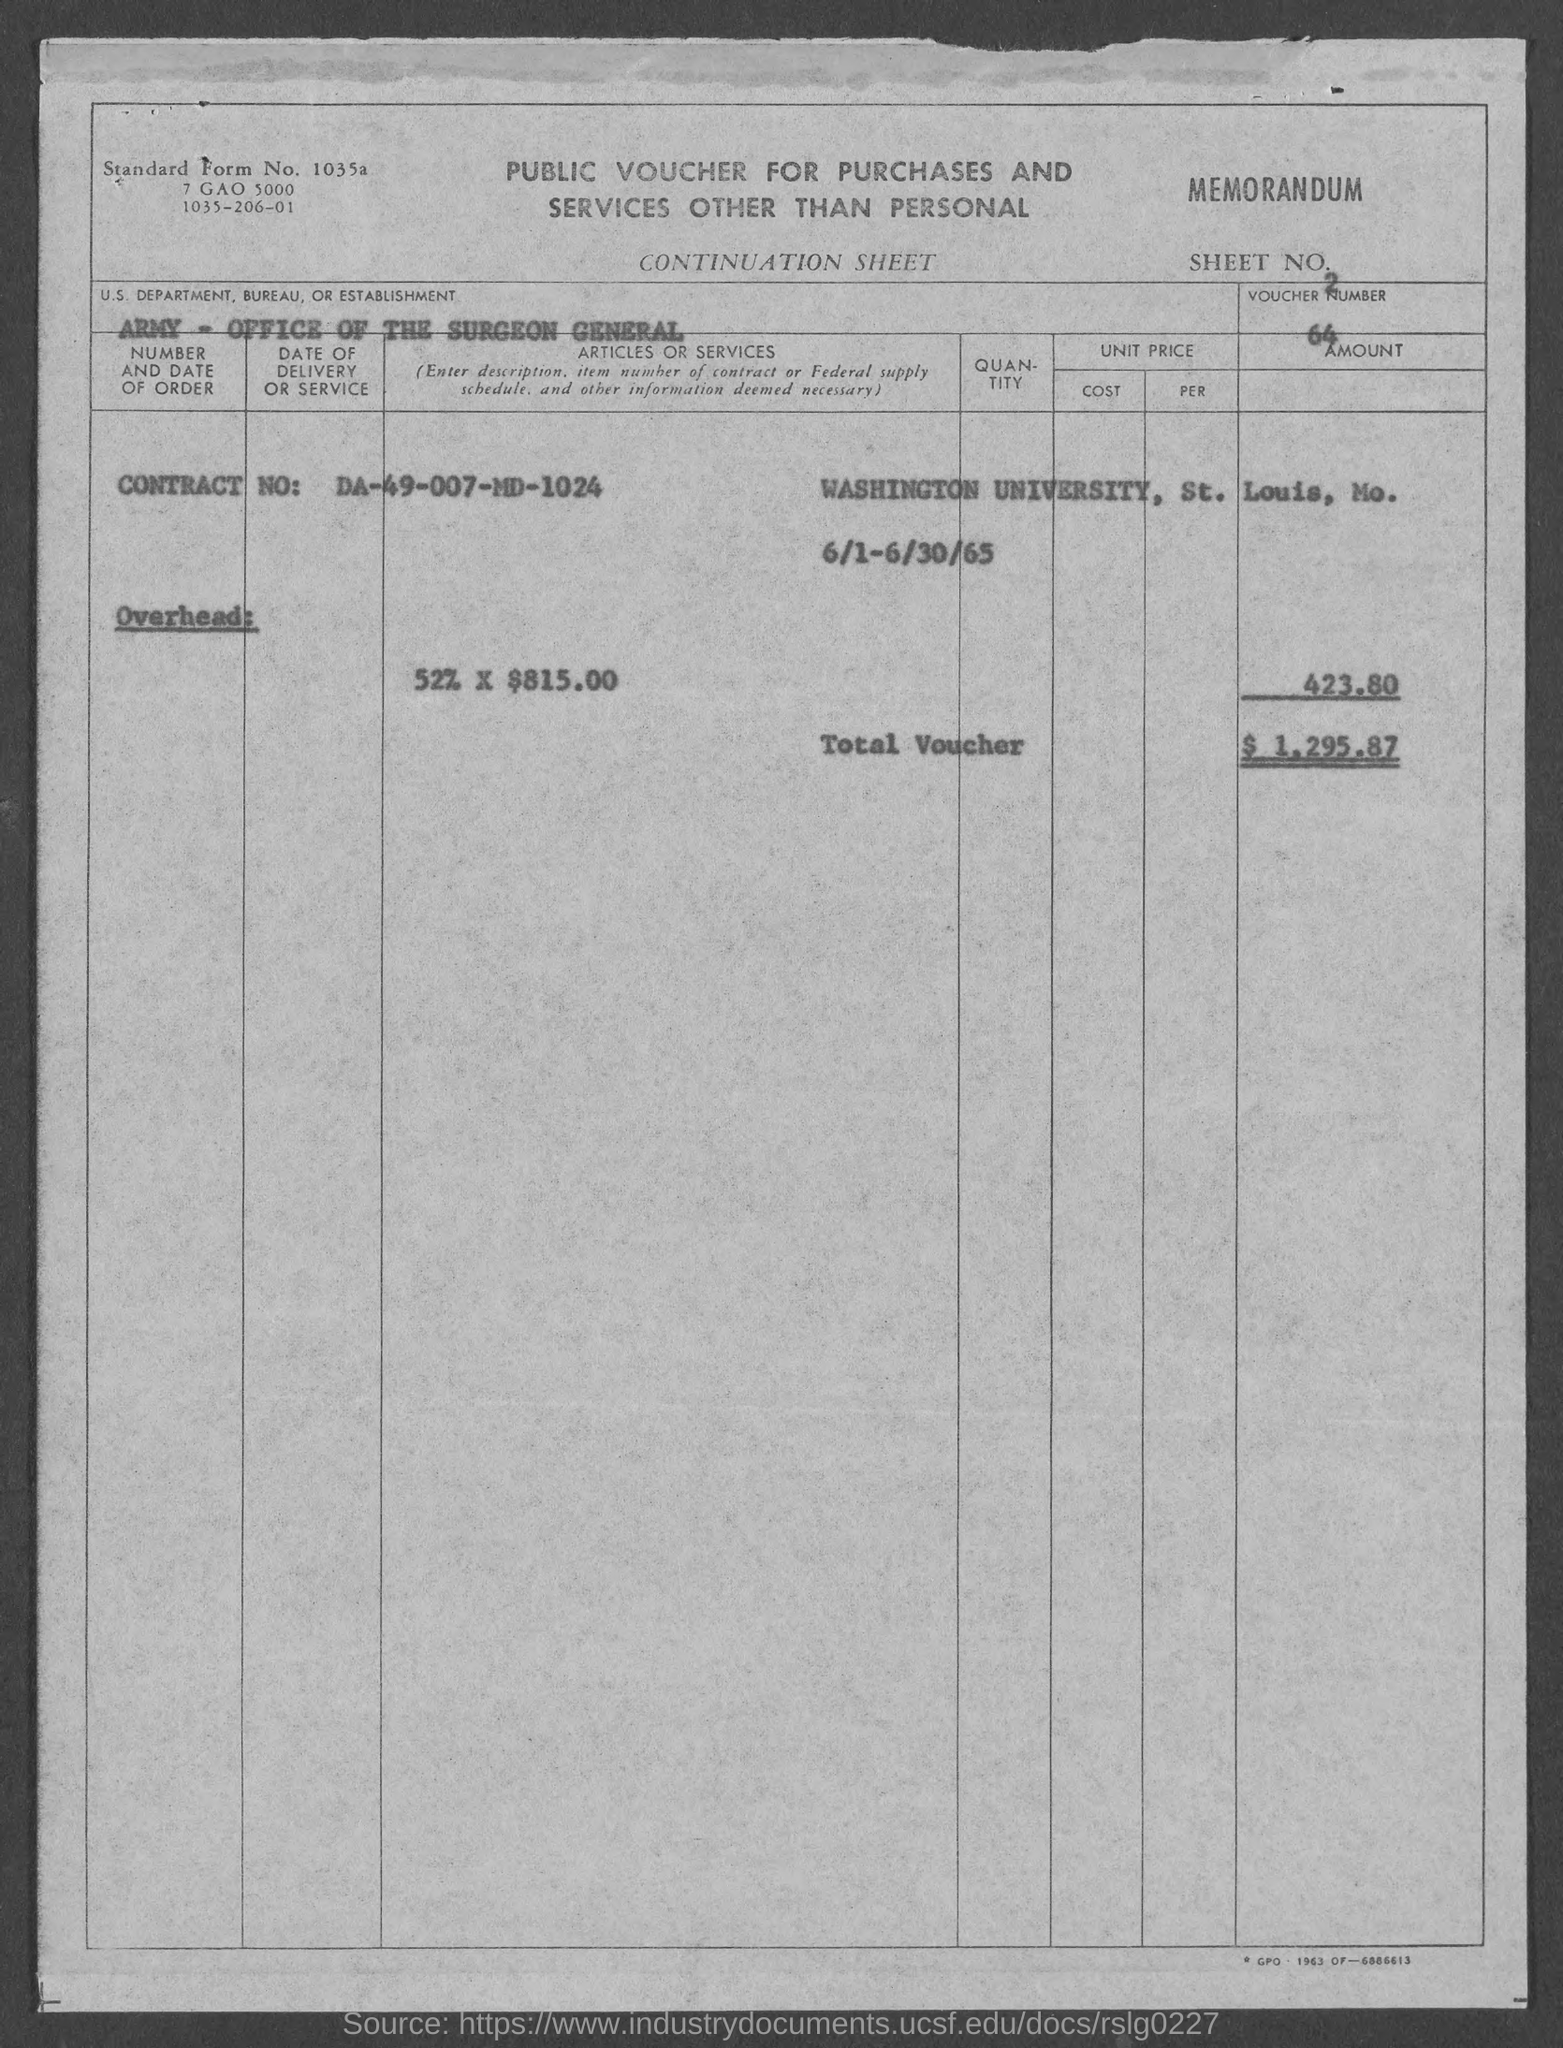What is the sheet no.?
Make the answer very short. 2. What is the voucher no.?
Your response must be concise. 64. What is the total voucher amount ?
Make the answer very short. $1,295.87. What is the contract number ?
Provide a succinct answer. DA-49-007-MD-1024. What is the us. department, bureau, or establishment ?
Give a very brief answer. Army- Office of the Surgeon General. 